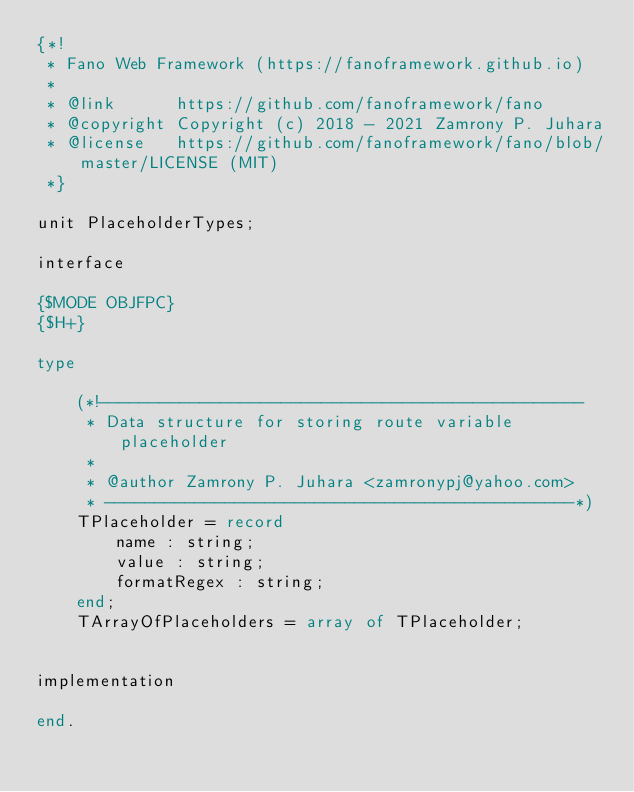Convert code to text. <code><loc_0><loc_0><loc_500><loc_500><_Pascal_>{*!
 * Fano Web Framework (https://fanoframework.github.io)
 *
 * @link      https://github.com/fanoframework/fano
 * @copyright Copyright (c) 2018 - 2021 Zamrony P. Juhara
 * @license   https://github.com/fanoframework/fano/blob/master/LICENSE (MIT)
 *}

unit PlaceholderTypes;

interface

{$MODE OBJFPC}
{$H+}

type

    (*!------------------------------------------------
     * Data structure for storing route variable placeholder
     *
     * @author Zamrony P. Juhara <zamronypj@yahoo.com>
     * -----------------------------------------------*)
    TPlaceholder = record
        name : string;
        value : string;
        formatRegex : string;
    end;
    TArrayOfPlaceholders = array of TPlaceholder;


implementation

end.
</code> 